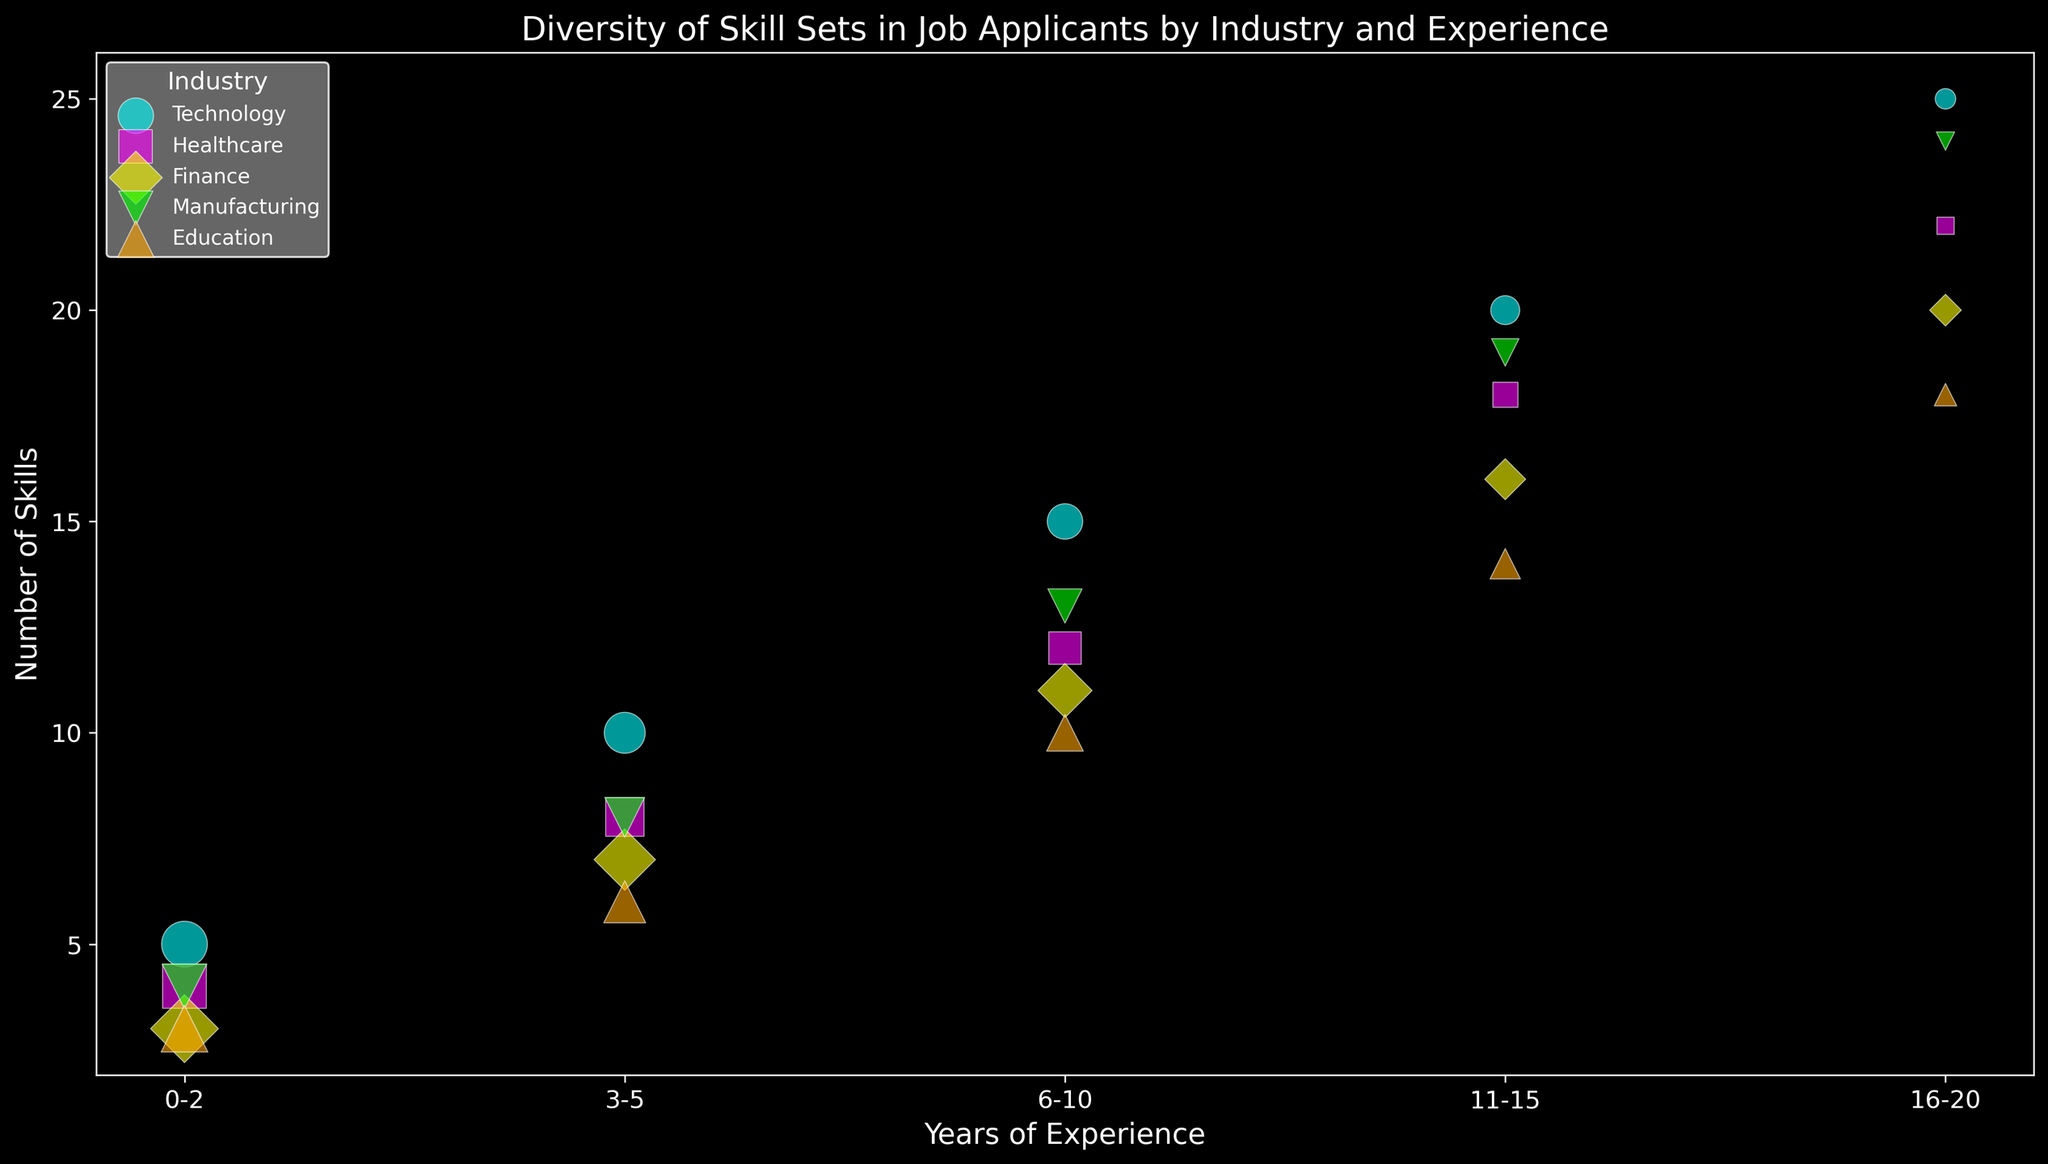What's the number of skills for applicants in Technology with 6-10 years of experience? Look for the 'Technology' entries and identify the '6-10' years of experience row; the number of skills is provided.
Answer: 15 Which industry has the largest bubble for applicants with 6-10 years of experience? Compare the size of bubbles (representing 'Number of Applicants') across industries for the '6-10' years category. The largest bubble indicates the greatest number of applicants.
Answer: Finance In Healthcare, which experience range has the highest number of skills? Search within the 'Healthcare' entries and compare the 'Number of Skills' across all experience ranges. The highest number will indicate the experience range.
Answer: 16-20 For Manufacturing, how does the number of skills for applicants with 3-5 years differ from those with 11-15 years of experience? Find the 'Number of Skills' for 'Manufacturing' for the '3-5' and '11-15' years ranges and compute the difference.
Answer: Difference is 11 Which industry has the least number of skills for applicants with 0-2 years of experience? Compare the 'Number of Skills' for the '0-2' years range across all industries and identify the least value.
Answer: Finance For applicants in Education, how does the number of applicants for 0-2 years of experience compare to 11-15 years of experience? Look at the 'Number of Applicants' column for 'Education' for both experience ranges and compare the two values.
Answer: 0-2 has 30 more applicants How many more skills do applicants in Technology have on average compared to those in Finance within the same '11-15' years experience range? Calculate the difference in the 'Number of Skills' between 'Technology' and 'Finance' within the '11-15' years experience range.
Answer: 4 more skills Which industry exhibits the highest diversity in the number of skills for applicants? Observe the spread and range of 'Number of Skills' across all experience ranges for each industry. The industry with the largest range demonstrates the highest diversity.
Answer: Technology What is the total number of applicants in the Finance industry with up to 10 years of experience? Sum up the 'Number of Applicants' for 'Finance' for the '0-2', '3-5', and '6-10' experience ranges.
Answer: 135 Which industry has the smallest bubble for applicants with 16-20 years of experience? Compare the size of bubbles (representing 'Number of Applicants') for the '16-20' years category across all industries and identify the smallest one.
Answer: Healthcare 